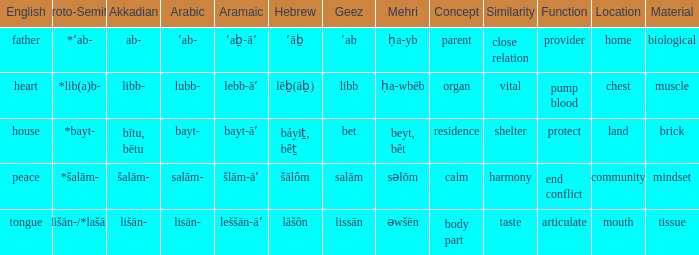What is the english equivalent of the aramaic term šlām-āʼ? Peace. 